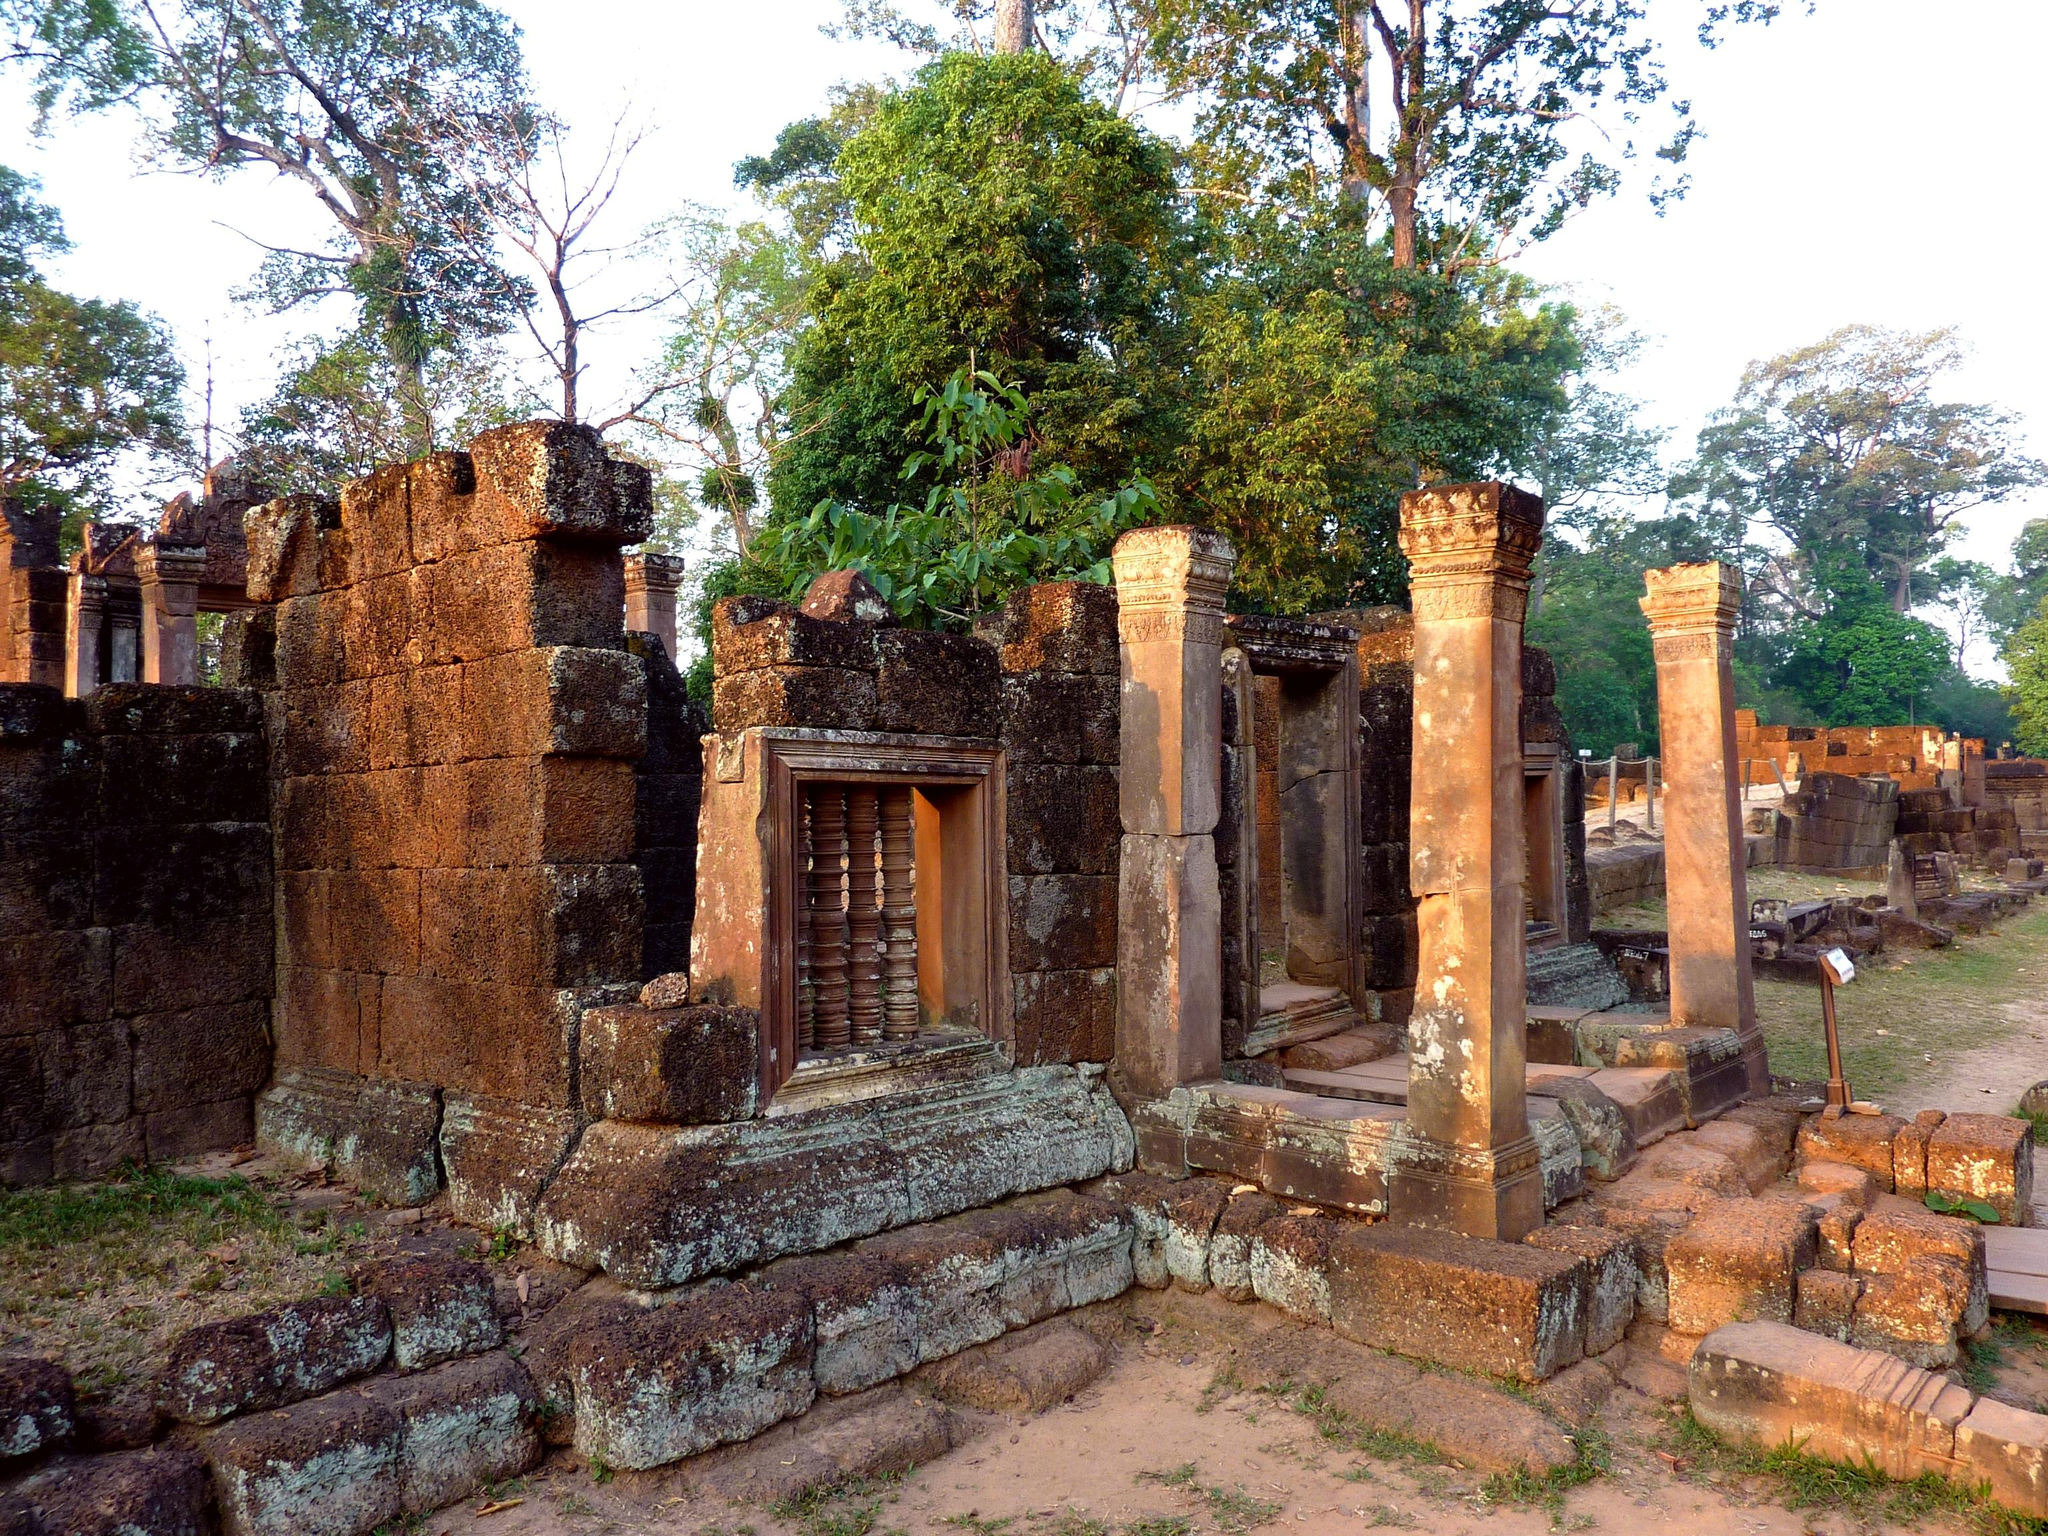What color are the walls and pillars in the image? The walls and pillars in the image are in brown color. What type of vegetation can be seen in the image? There are trees in green color in the image. What color is the sky in the image? The sky is in white color in the image. How many kittens are playing on the train in the image? There are no kittens or trains present in the image. Can you see a bat flying in the sky in the image? There is no bat visible in the sky in the image. 